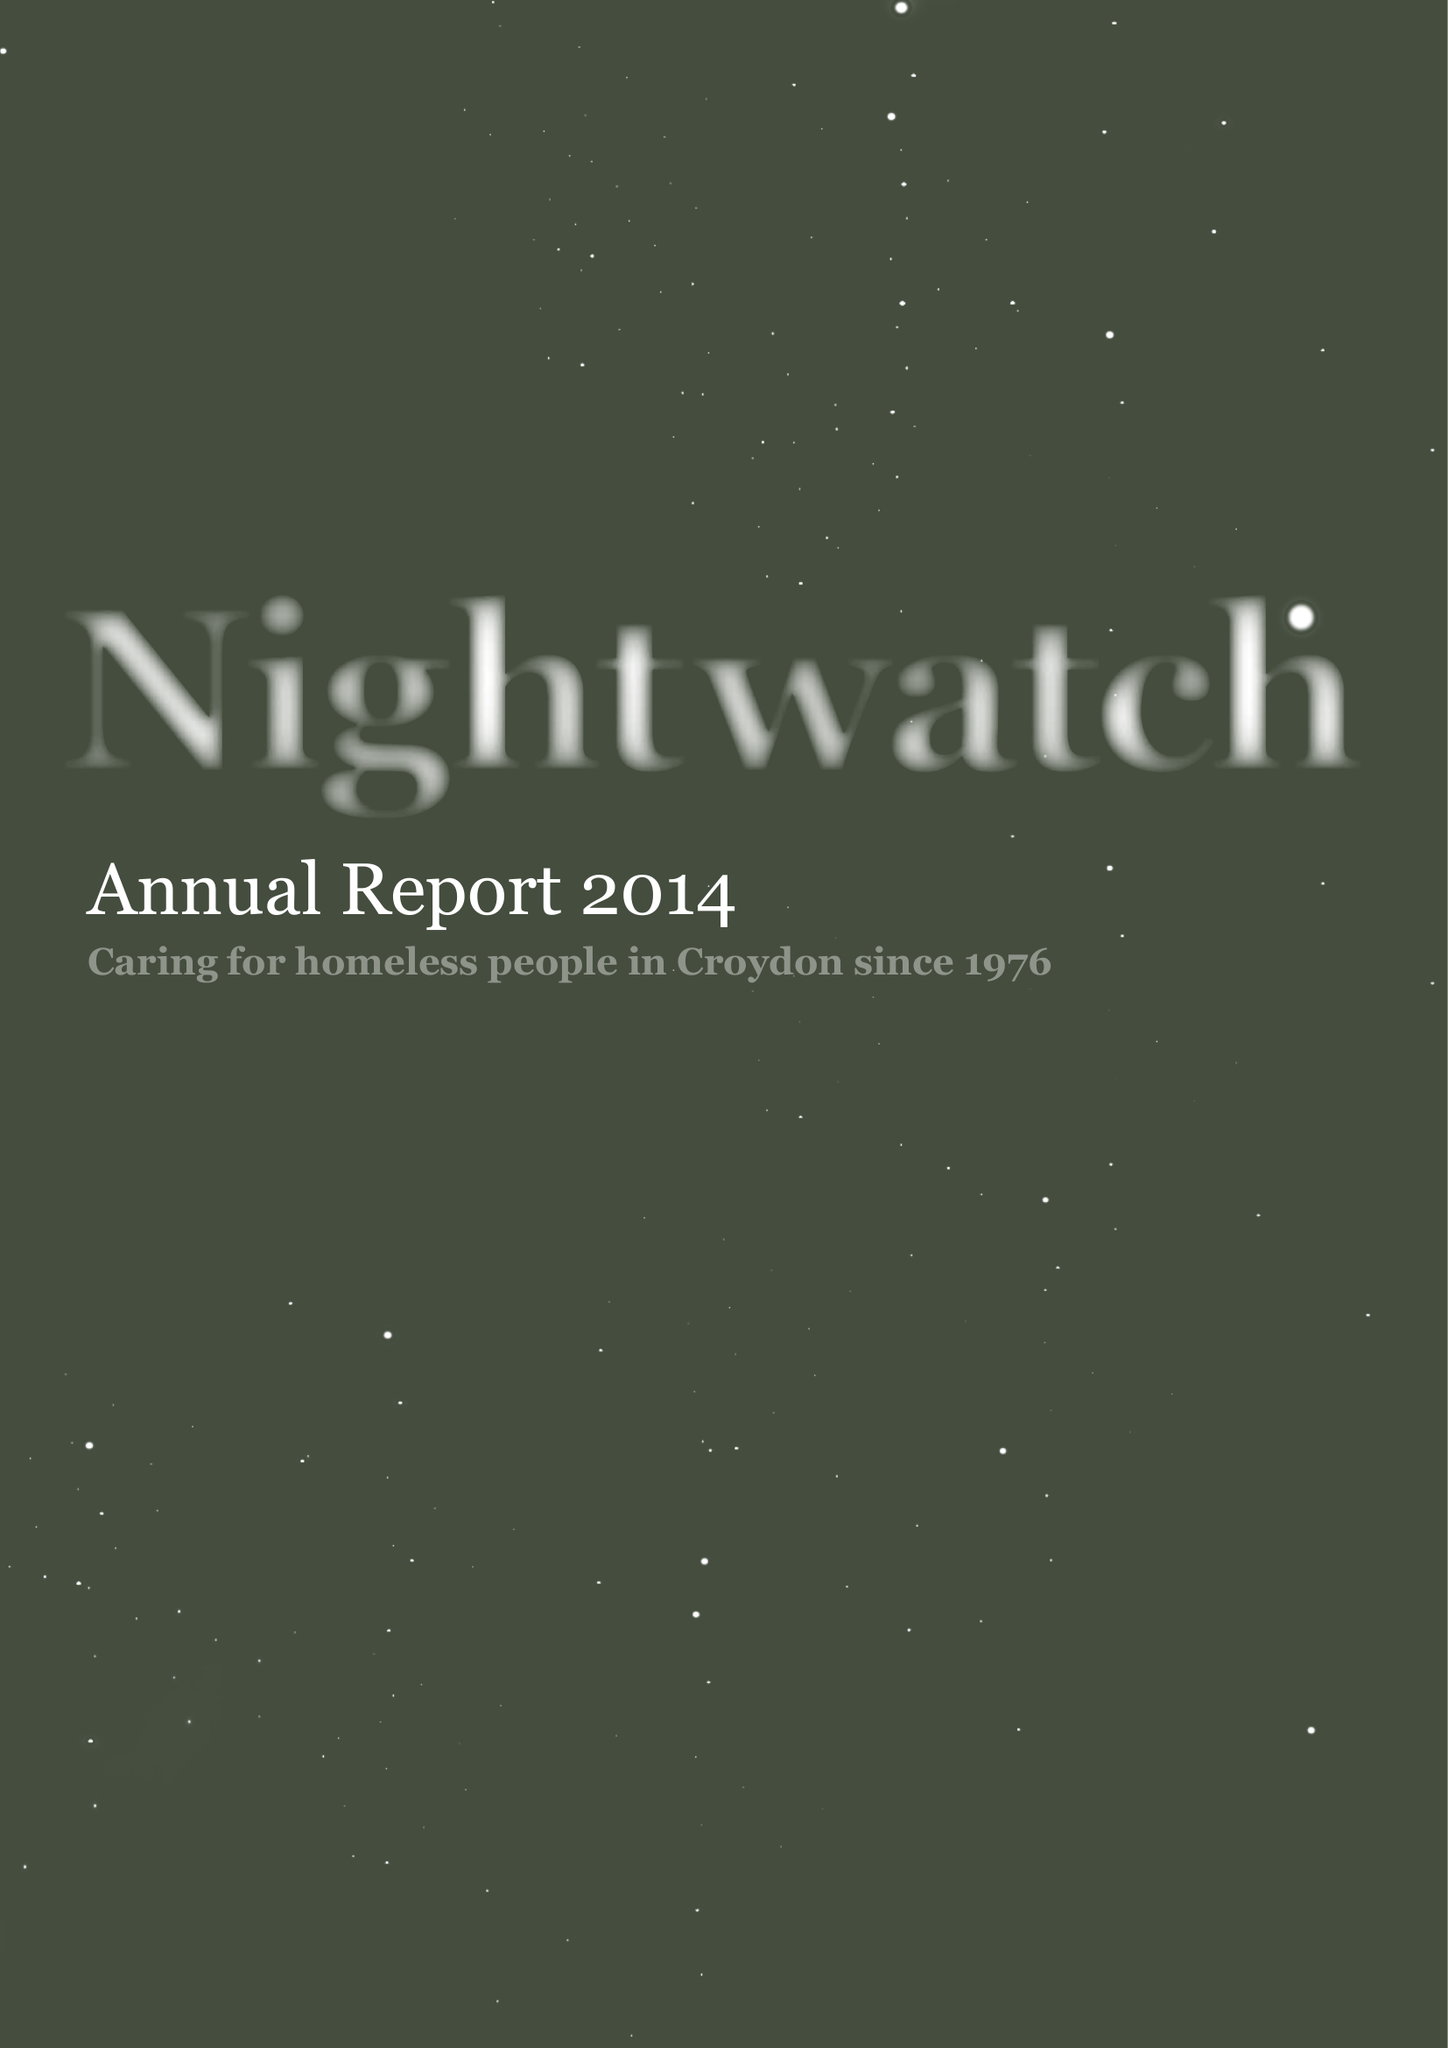What is the value for the charity_number?
Answer the question using a single word or phrase. 274925 